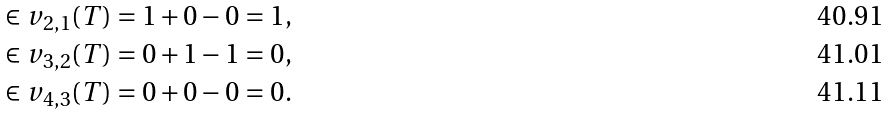<formula> <loc_0><loc_0><loc_500><loc_500>\in v _ { 2 , 1 } ( T ) & = 1 + 0 - 0 = 1 , \\ \in v _ { 3 , 2 } ( T ) & = 0 + 1 - 1 = 0 , \\ \in v _ { 4 , 3 } ( T ) & = 0 + 0 - 0 = 0 .</formula> 